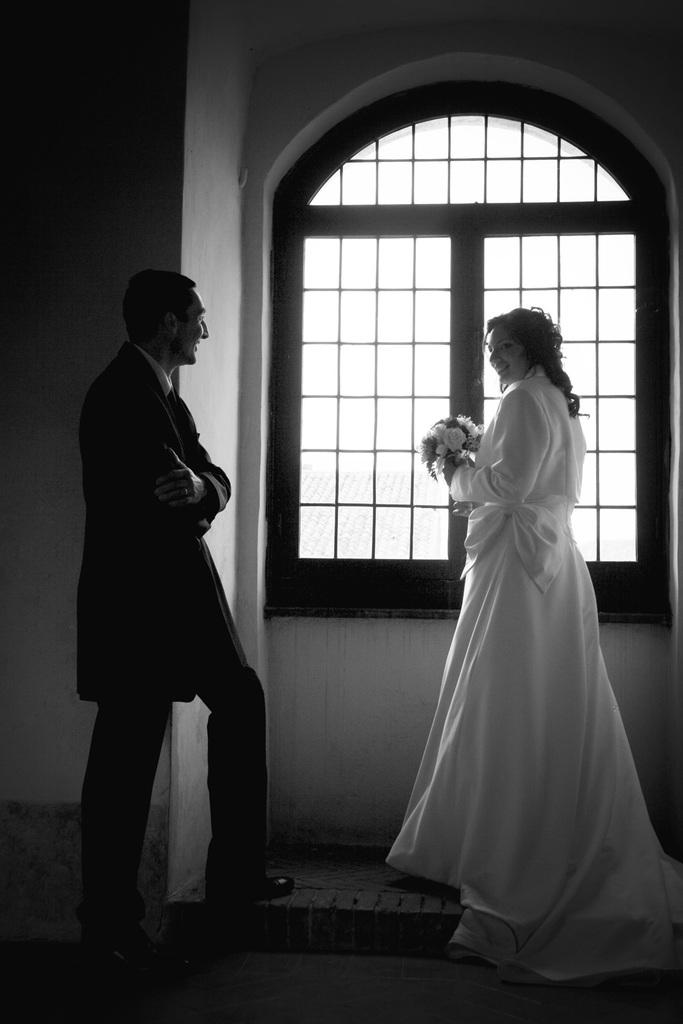How many people are in the image? There are two persons standing and smiling in the image. What is one person holding in the image? One person is holding a flower bouquet. What can be seen in the background of the image? There is a window and a wall in the background of the image. What type of knowledge can be seen in the hands of the person holding the flower bouquet? There is no knowledge visible in the image, as the person is holding a flower bouquet, not any form of knowledge. 